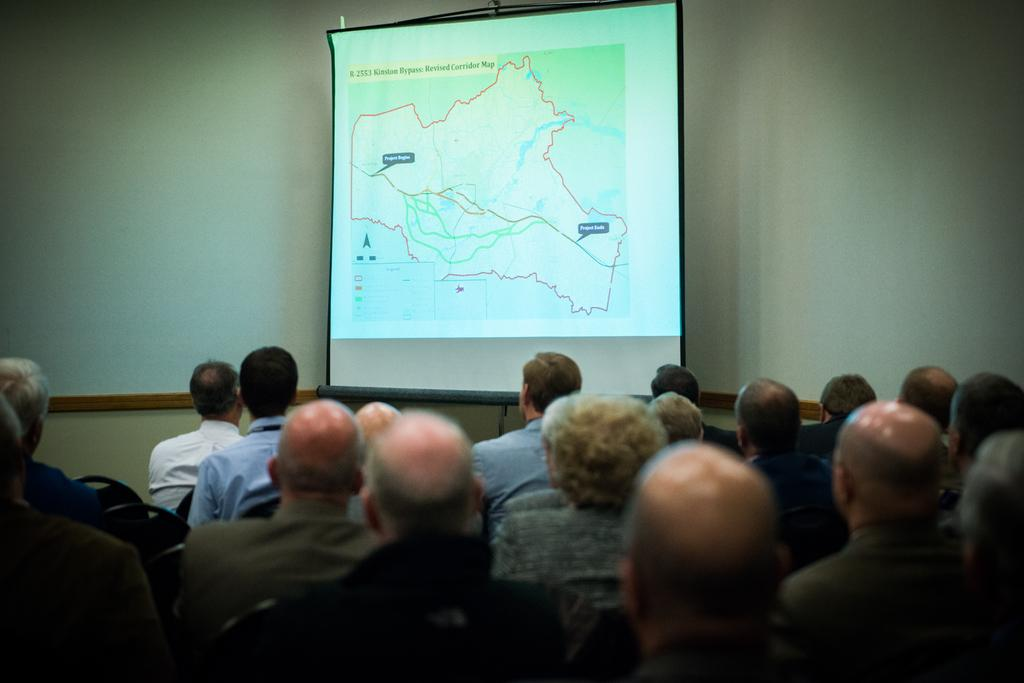What is happening at the bottom of the image? There is a group of people sitting at the bottom of the image. What is located at the top of the image? There is a projector screen at the top of the image. What type of meat is being served at the event in the image? There is no indication of any food, including meat, being served in the image. The focus is on the group of people sitting at the bottom and the projector screen at the top. 